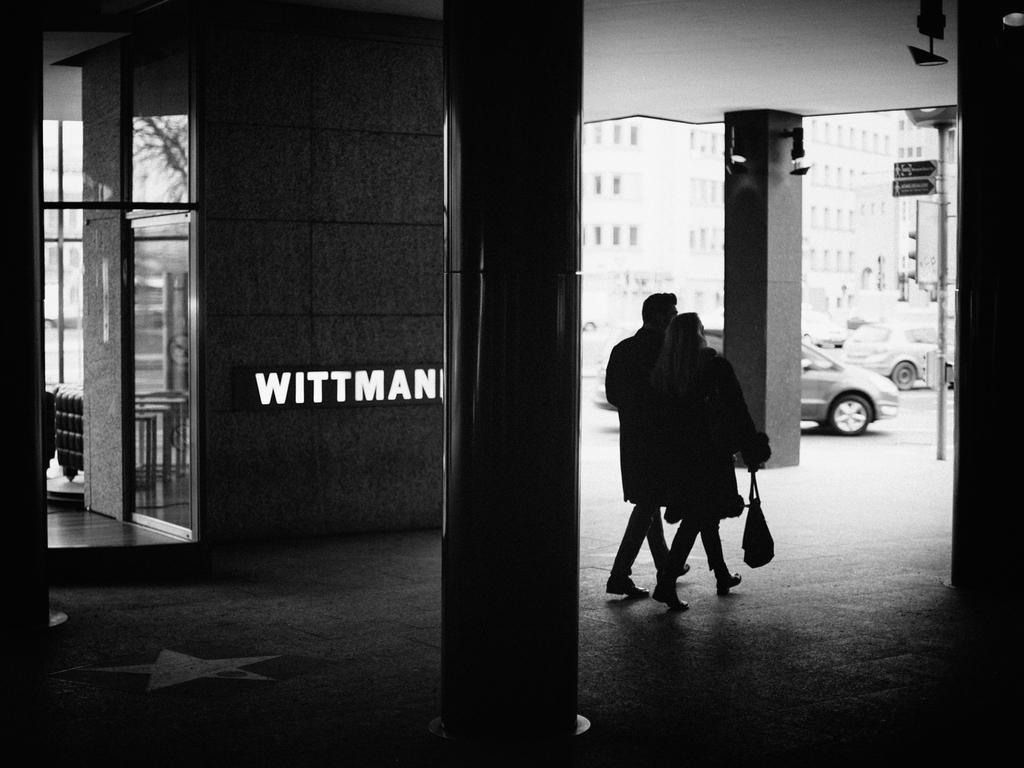In one or two sentences, can you explain what this image depicts? In this image we can see a man and a woman walking on the floor, woman is holding a handbag, there are few pillars, there are cars and a building in the background and a pole with a sign board, there are objects looks like lights attached to the pillar and some text written on the wall. 